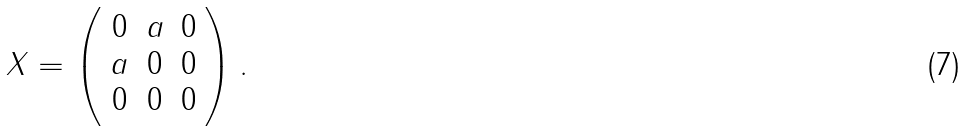Convert formula to latex. <formula><loc_0><loc_0><loc_500><loc_500>X = \left ( \begin{array} { c c c } 0 & a & 0 \\ a & 0 & 0 \\ 0 & 0 & 0 \end{array} \right ) .</formula> 